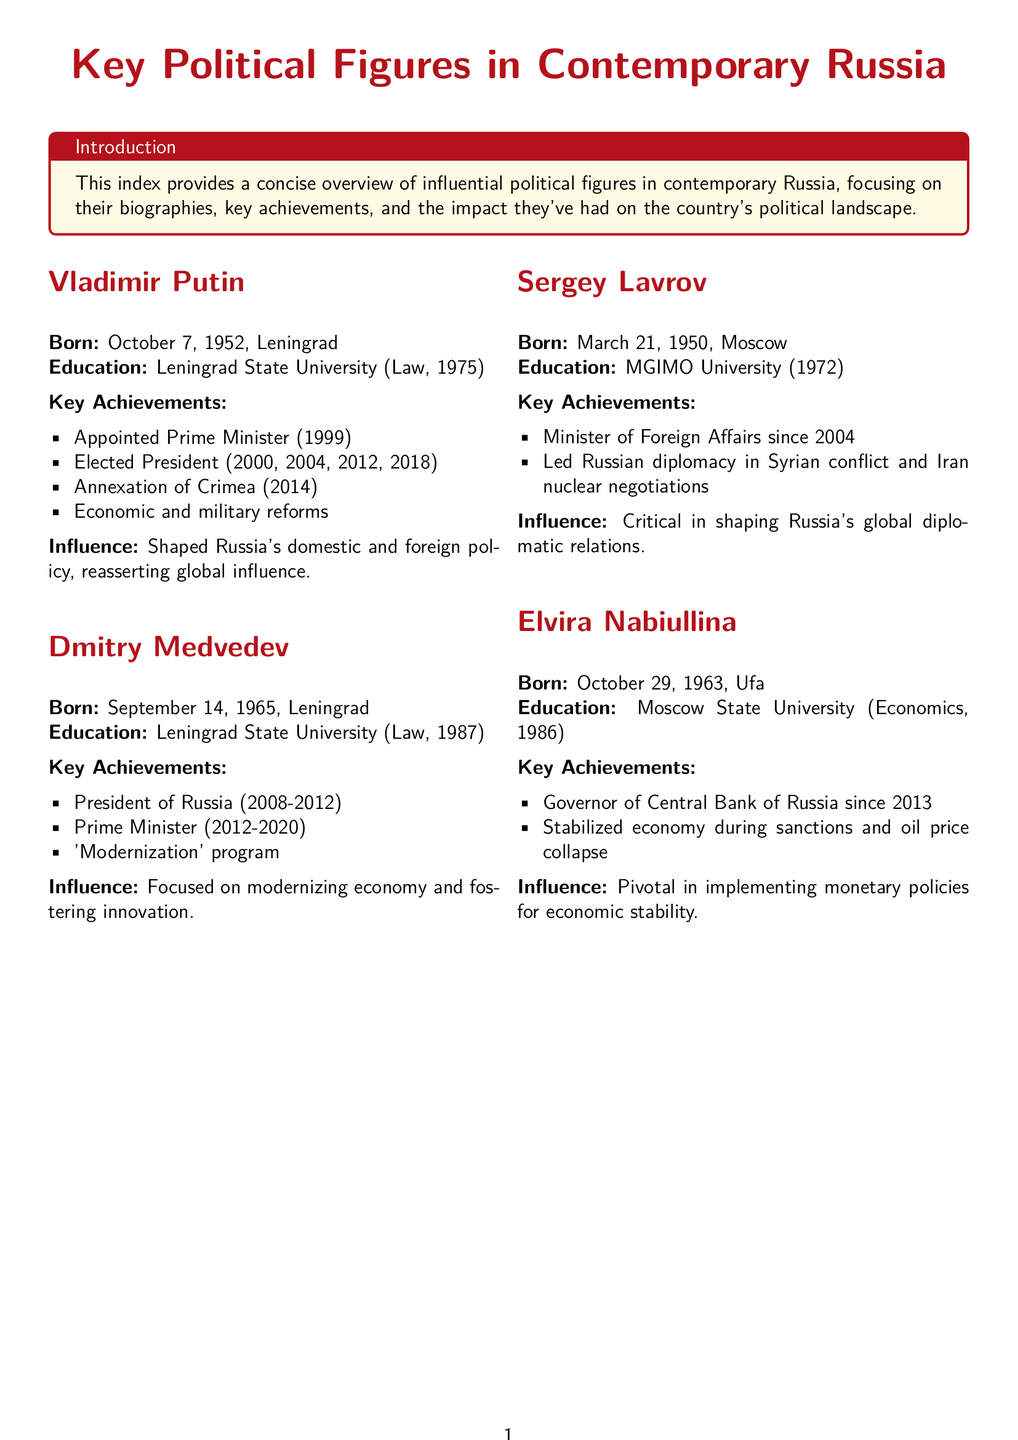What is Vladimir Putin's birth date? The document states that Vladimir Putin was born on October 7, 1952.
Answer: October 7, 1952 Who was President of Russia from 2008 to 2012? The document indicates that Dmitry Medvedev served as President during this period.
Answer: Dmitry Medvedev What university did Sergey Lavrov graduate from? The document mentions that Sergey Lavrov graduated from MGIMO University.
Answer: MGIMO University When did Elvira Nabiullina become the Governor of the Central Bank of Russia? According to the document, Elvira Nabiullina has been in this position since 2013.
Answer: 2013 Which figure is noted for stabilizing the economy during sanctions? The document credits Elvira Nabiullina for this achievement.
Answer: Elvira Nabiullina What key policy did Dmitry Medvedev focus on during his presidency? The document highlights Medvedev's focus on the 'Modernization' program.
Answer: 'Modernization' program How long has Sergey Lavrov been the Minister of Foreign Affairs? The document states he has held this position since 2004.
Answer: Since 2004 What major event is Vladimir Putin associated with in 2014? The document specifies the annexation of Crimea in 2014 as a key event.
Answer: Annexation of Crimea What is the primary role of Elvira Nabiullina? The document describes her as the Governor of the Central Bank of Russia.
Answer: Governor of the Central Bank of Russia 